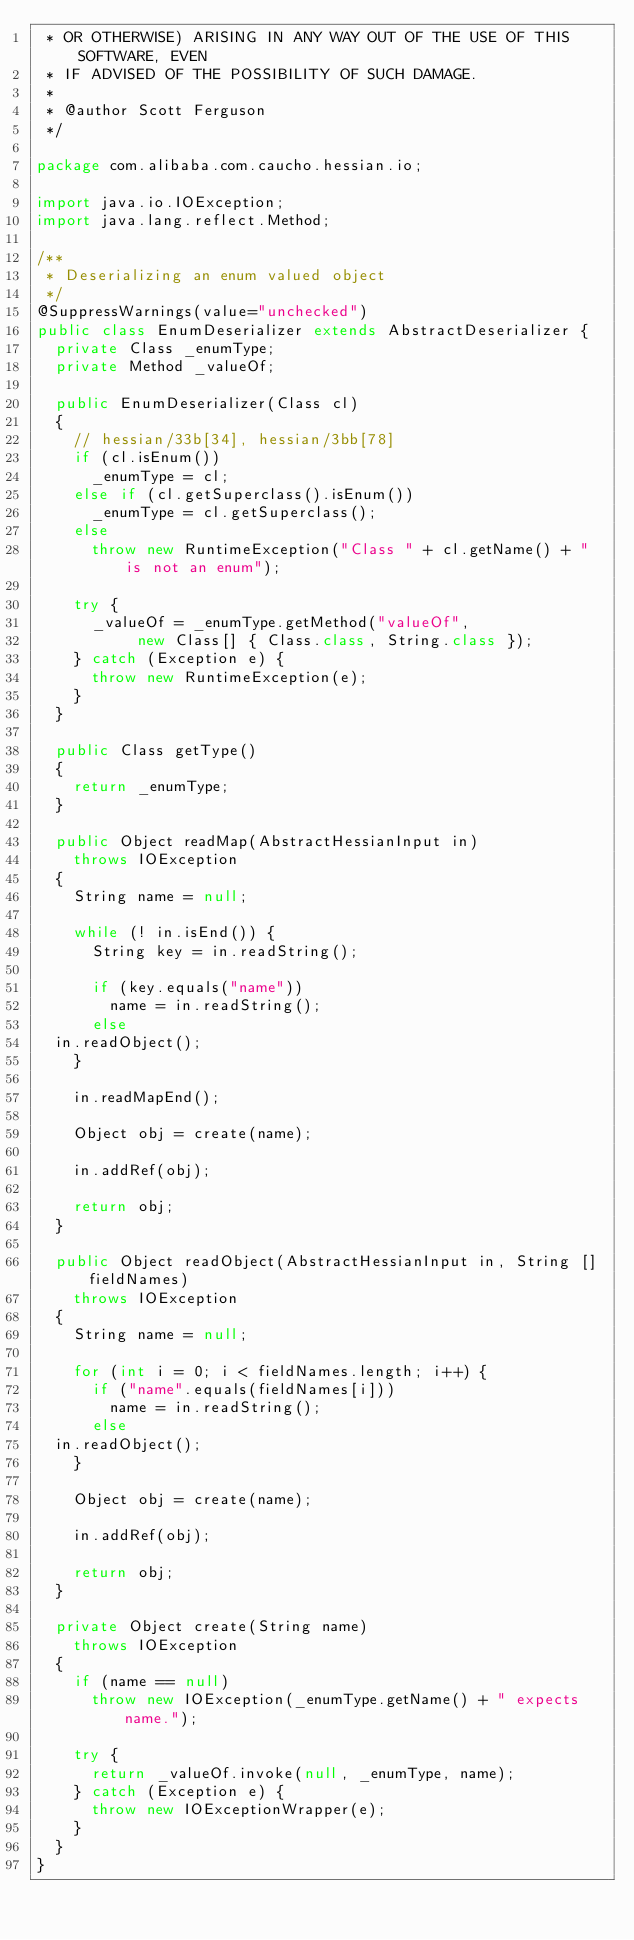Convert code to text. <code><loc_0><loc_0><loc_500><loc_500><_Java_> * OR OTHERWISE) ARISING IN ANY WAY OUT OF THE USE OF THIS SOFTWARE, EVEN
 * IF ADVISED OF THE POSSIBILITY OF SUCH DAMAGE.
 *
 * @author Scott Ferguson
 */

package com.alibaba.com.caucho.hessian.io;

import java.io.IOException;
import java.lang.reflect.Method;

/**
 * Deserializing an enum valued object
 */
@SuppressWarnings(value="unchecked")
public class EnumDeserializer extends AbstractDeserializer {
  private Class _enumType;
  private Method _valueOf;
  
  public EnumDeserializer(Class cl)
  {
    // hessian/33b[34], hessian/3bb[78]
    if (cl.isEnum())
      _enumType = cl;
    else if (cl.getSuperclass().isEnum())
      _enumType = cl.getSuperclass();
    else
      throw new RuntimeException("Class " + cl.getName() + " is not an enum");

    try {
      _valueOf = _enumType.getMethod("valueOf",
			     new Class[] { Class.class, String.class });
    } catch (Exception e) {
      throw new RuntimeException(e);
    }
  }
  
  public Class getType()
  {
    return _enumType;
  }
  
  public Object readMap(AbstractHessianInput in)
    throws IOException
  {
    String name = null;
    
    while (! in.isEnd()) {
      String key = in.readString();

      if (key.equals("name"))
        name = in.readString();
      else
	in.readObject();
    }

    in.readMapEnd();

    Object obj = create(name);
    
    in.addRef(obj);

    return obj;
  }
  
  public Object readObject(AbstractHessianInput in, String []fieldNames)
    throws IOException
  {
    String name = null;

    for (int i = 0; i < fieldNames.length; i++) {
      if ("name".equals(fieldNames[i]))
        name = in.readString();
      else
	in.readObject();
    }

    Object obj = create(name);

    in.addRef(obj);

    return obj;
  }

  private Object create(String name)
    throws IOException
  {
    if (name == null)
      throw new IOException(_enumType.getName() + " expects name.");

    try {
      return _valueOf.invoke(null, _enumType, name);
    } catch (Exception e) {
      throw new IOExceptionWrapper(e);
    }
  }
}
</code> 